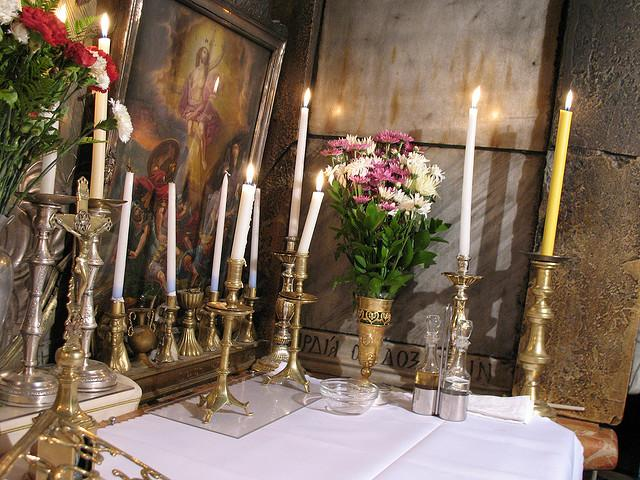What state are the candles in? lit 